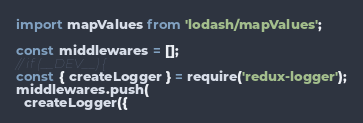Convert code to text. <code><loc_0><loc_0><loc_500><loc_500><_JavaScript_>import mapValues from 'lodash/mapValues';

const middlewares = [];
// if (__DEV__) {
const { createLogger } = require('redux-logger');
middlewares.push(
  createLogger({</code> 